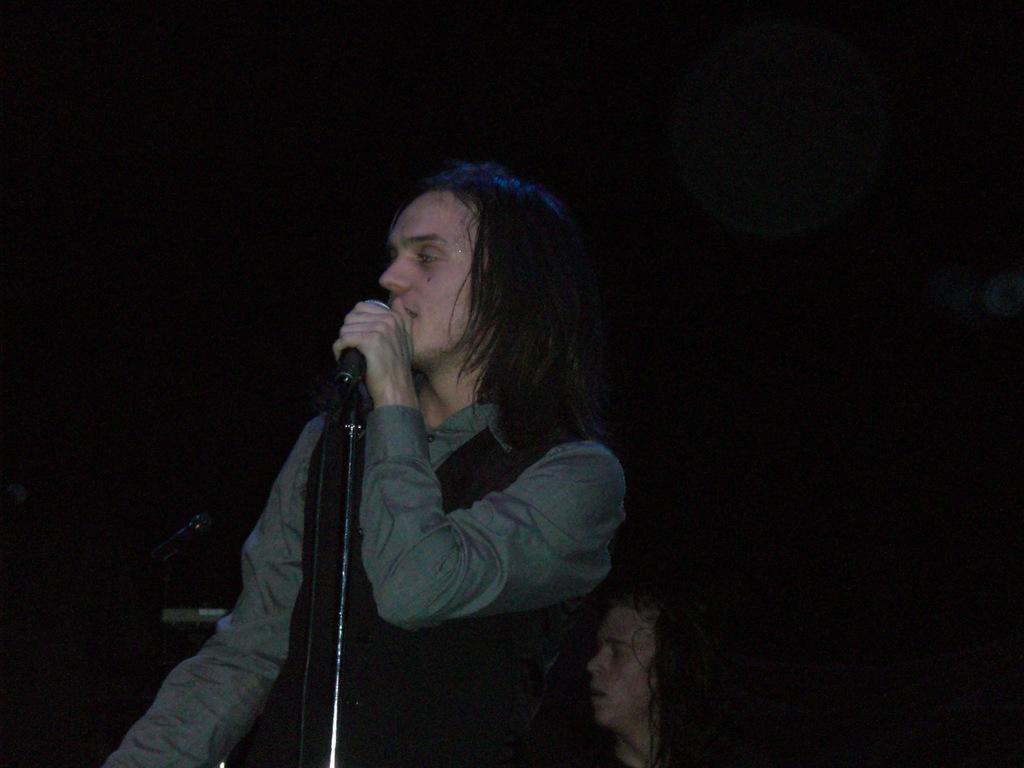Please provide a concise description of this image. In the foreground of this image, there is a man standing and holding a mic which is in front to him. In the background, there is a man, mick and remaining is dark. 